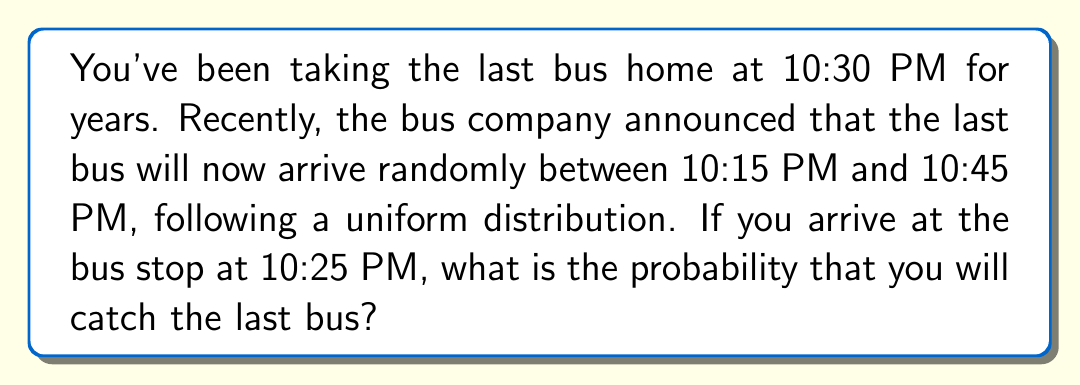Can you answer this question? Let's approach this step-by-step:

1) The bus arrival time follows a uniform distribution between 10:15 PM and 10:45 PM. This means the probability of the bus arriving at any time within this interval is equally likely.

2) We need to find the probability that the bus arrives after 10:25 PM (when you arrive at the stop).

3) Let's define our random variable $X$ as the arrival time of the bus in minutes past 10:00 PM.

4) The uniform distribution has a range from 15 to 45 minutes past 10:00 PM.

5) The probability density function for a uniform distribution is:

   $$f(x) = \frac{1}{b-a}$$

   where $a$ is the minimum value and $b$ is the maximum value.

6) In this case, $a = 15$ and $b = 45$, so:

   $$f(x) = \frac{1}{45-15} = \frac{1}{30}$$

7) The probability we're looking for is:

   $$P(X > 25) = \int_{25}^{45} \frac{1}{30} dx$$

8) Solving the integral:

   $$P(X > 25) = \left[\frac{x}{30}\right]_{25}^{45} = \frac{45}{30} - \frac{25}{30} = \frac{20}{30} = \frac{2}{3}$$

Therefore, the probability of catching the bus is $\frac{2}{3}$ or approximately 0.6667.
Answer: $\frac{2}{3}$ 